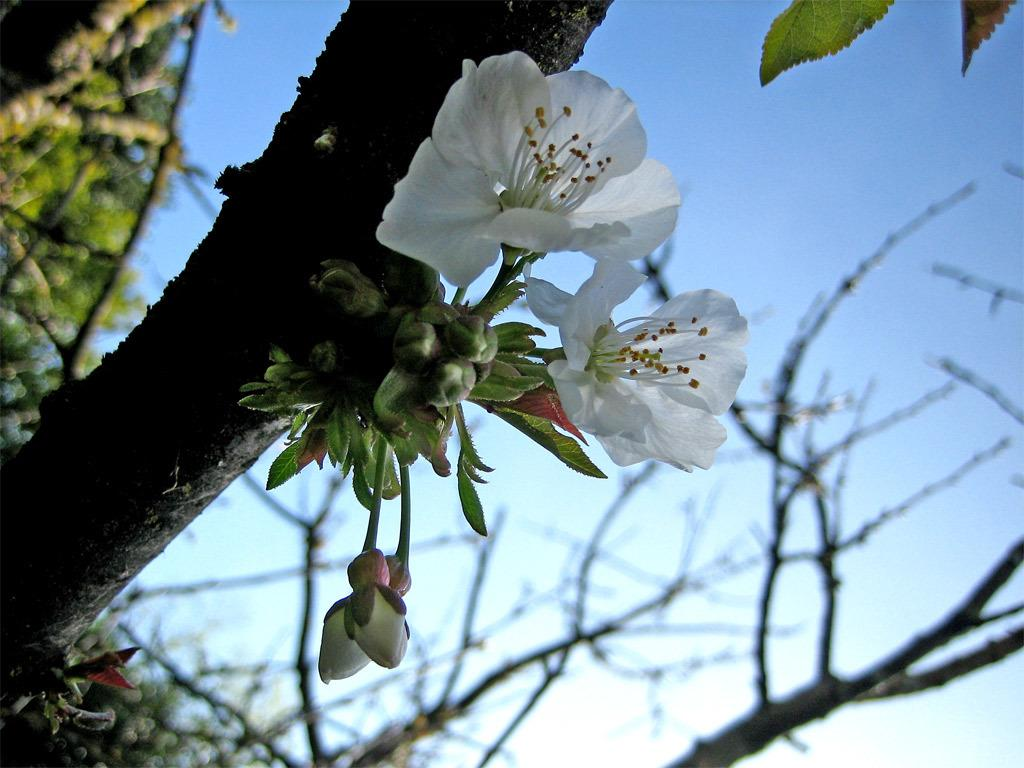What is present on the branch in the image? There are flowers and buds on a branch in the image. What can be seen in the background of the image? There are trees and the sky visible in the background of the image. Where are the leaves located in the image? The leaves are in the top right corner of the image. How does the wool provide comfort in the image? There is no wool present in the image, so it cannot provide comfort. 